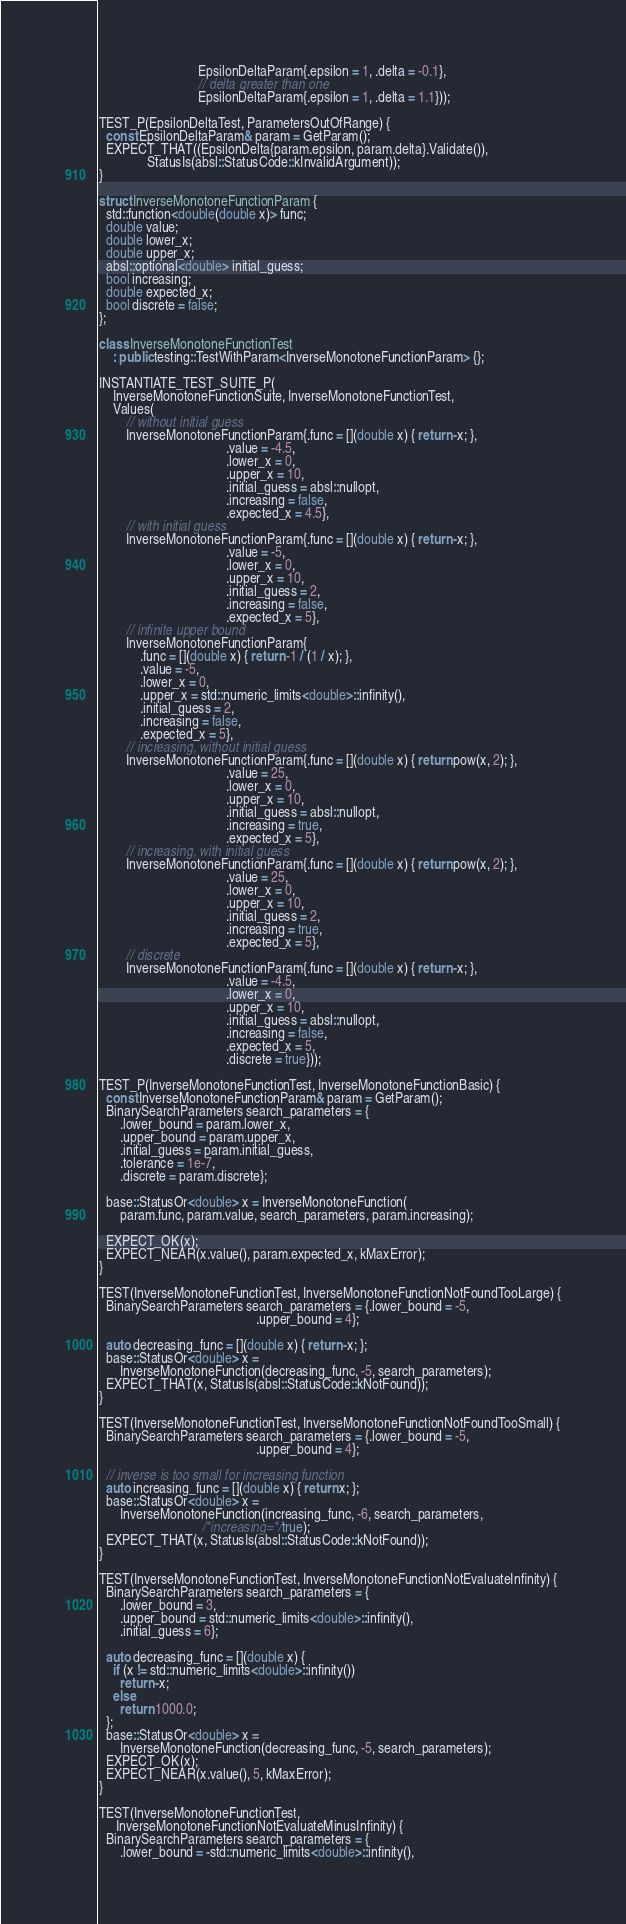Convert code to text. <code><loc_0><loc_0><loc_500><loc_500><_C++_>                             EpsilonDeltaParam{.epsilon = 1, .delta = -0.1},
                             // delta greater than one
                             EpsilonDeltaParam{.epsilon = 1, .delta = 1.1}));

TEST_P(EpsilonDeltaTest, ParametersOutOfRange) {
  const EpsilonDeltaParam& param = GetParam();
  EXPECT_THAT((EpsilonDelta{param.epsilon, param.delta}.Validate()),
              StatusIs(absl::StatusCode::kInvalidArgument));
}

struct InverseMonotoneFunctionParam {
  std::function<double(double x)> func;
  double value;
  double lower_x;
  double upper_x;
  absl::optional<double> initial_guess;
  bool increasing;
  double expected_x;
  bool discrete = false;
};

class InverseMonotoneFunctionTest
    : public testing::TestWithParam<InverseMonotoneFunctionParam> {};

INSTANTIATE_TEST_SUITE_P(
    InverseMonotoneFunctionSuite, InverseMonotoneFunctionTest,
    Values(
        // without initial guess
        InverseMonotoneFunctionParam{.func = [](double x) { return -x; },
                                     .value = -4.5,
                                     .lower_x = 0,
                                     .upper_x = 10,
                                     .initial_guess = absl::nullopt,
                                     .increasing = false,
                                     .expected_x = 4.5},
        // with initial guess
        InverseMonotoneFunctionParam{.func = [](double x) { return -x; },
                                     .value = -5,
                                     .lower_x = 0,
                                     .upper_x = 10,
                                     .initial_guess = 2,
                                     .increasing = false,
                                     .expected_x = 5},
        // infinite upper bound
        InverseMonotoneFunctionParam{
            .func = [](double x) { return -1 / (1 / x); },
            .value = -5,
            .lower_x = 0,
            .upper_x = std::numeric_limits<double>::infinity(),
            .initial_guess = 2,
            .increasing = false,
            .expected_x = 5},
        // increasing, without initial guess
        InverseMonotoneFunctionParam{.func = [](double x) { return pow(x, 2); },
                                     .value = 25,
                                     .lower_x = 0,
                                     .upper_x = 10,
                                     .initial_guess = absl::nullopt,
                                     .increasing = true,
                                     .expected_x = 5},
        // increasing, with initial guess
        InverseMonotoneFunctionParam{.func = [](double x) { return pow(x, 2); },
                                     .value = 25,
                                     .lower_x = 0,
                                     .upper_x = 10,
                                     .initial_guess = 2,
                                     .increasing = true,
                                     .expected_x = 5},
        // discrete
        InverseMonotoneFunctionParam{.func = [](double x) { return -x; },
                                     .value = -4.5,
                                     .lower_x = 0,
                                     .upper_x = 10,
                                     .initial_guess = absl::nullopt,
                                     .increasing = false,
                                     .expected_x = 5,
                                     .discrete = true}));

TEST_P(InverseMonotoneFunctionTest, InverseMonotoneFunctionBasic) {
  const InverseMonotoneFunctionParam& param = GetParam();
  BinarySearchParameters search_parameters = {
      .lower_bound = param.lower_x,
      .upper_bound = param.upper_x,
      .initial_guess = param.initial_guess,
      .tolerance = 1e-7,
      .discrete = param.discrete};

  base::StatusOr<double> x = InverseMonotoneFunction(
      param.func, param.value, search_parameters, param.increasing);

  EXPECT_OK(x);
  EXPECT_NEAR(x.value(), param.expected_x, kMaxError);
}

TEST(InverseMonotoneFunctionTest, InverseMonotoneFunctionNotFoundTooLarge) {
  BinarySearchParameters search_parameters = {.lower_bound = -5,
                                              .upper_bound = 4};

  auto decreasing_func = [](double x) { return -x; };
  base::StatusOr<double> x =
      InverseMonotoneFunction(decreasing_func, -5, search_parameters);
  EXPECT_THAT(x, StatusIs(absl::StatusCode::kNotFound));
}

TEST(InverseMonotoneFunctionTest, InverseMonotoneFunctionNotFoundTooSmall) {
  BinarySearchParameters search_parameters = {.lower_bound = -5,
                                              .upper_bound = 4};

  // inverse is too small for increasing function
  auto increasing_func = [](double x) { return x; };
  base::StatusOr<double> x =
      InverseMonotoneFunction(increasing_func, -6, search_parameters,
                              /*increasing=*/true);
  EXPECT_THAT(x, StatusIs(absl::StatusCode::kNotFound));
}

TEST(InverseMonotoneFunctionTest, InverseMonotoneFunctionNotEvaluateInfinity) {
  BinarySearchParameters search_parameters = {
      .lower_bound = 3,
      .upper_bound = std::numeric_limits<double>::infinity(),
      .initial_guess = 6};

  auto decreasing_func = [](double x) {
    if (x != std::numeric_limits<double>::infinity())
      return -x;
    else
      return 1000.0;
  };
  base::StatusOr<double> x =
      InverseMonotoneFunction(decreasing_func, -5, search_parameters);
  EXPECT_OK(x);
  EXPECT_NEAR(x.value(), 5, kMaxError);
}

TEST(InverseMonotoneFunctionTest,
     InverseMonotoneFunctionNotEvaluateMinusInfinity) {
  BinarySearchParameters search_parameters = {
      .lower_bound = -std::numeric_limits<double>::infinity(),</code> 